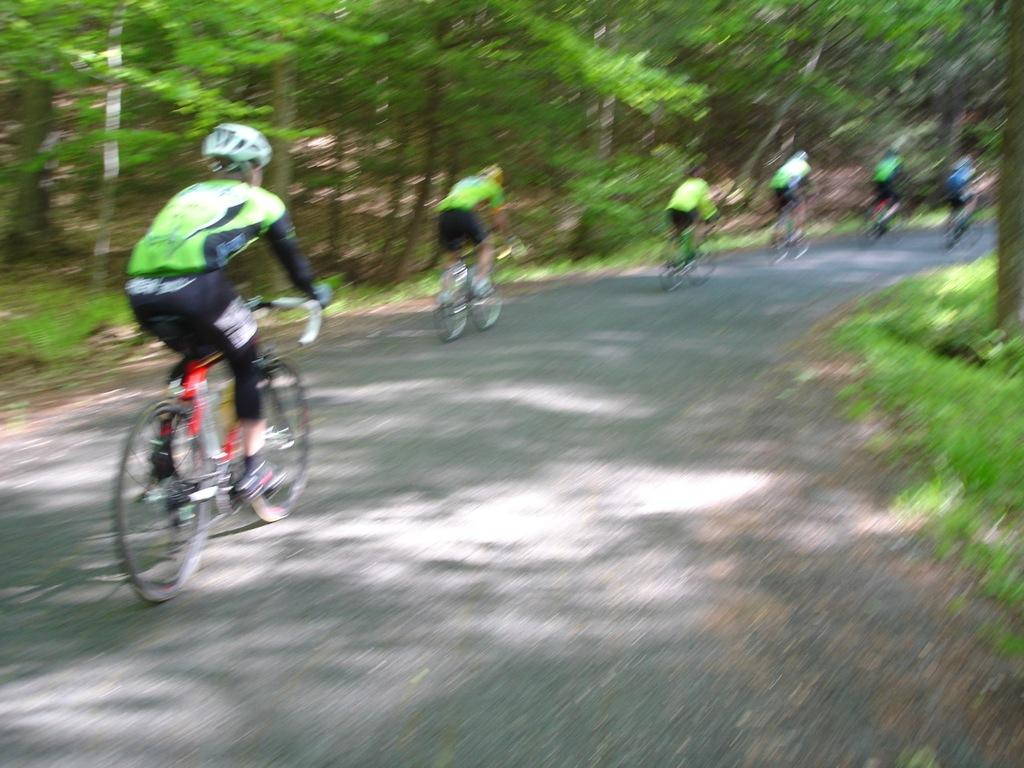What activity are the people in the image engaged in? The people in the image are cycling on the road. Where are the cyclists located in the image? The cyclists are in the center of the image. What type of vegetation is present on the right side of the image? There is grass on the surface on the right side of the image. What can be seen in the background of the image? There are trees in the background of the image. What type of cheese is being requested by the cyclists in the image? There is no cheese or request present in the image; it features people cycling on the road. How do the cyclists maintain their grip on the handlebars in the image? The image does not show the cyclists' grip on the handlebars, so it cannot be determined from the image. 